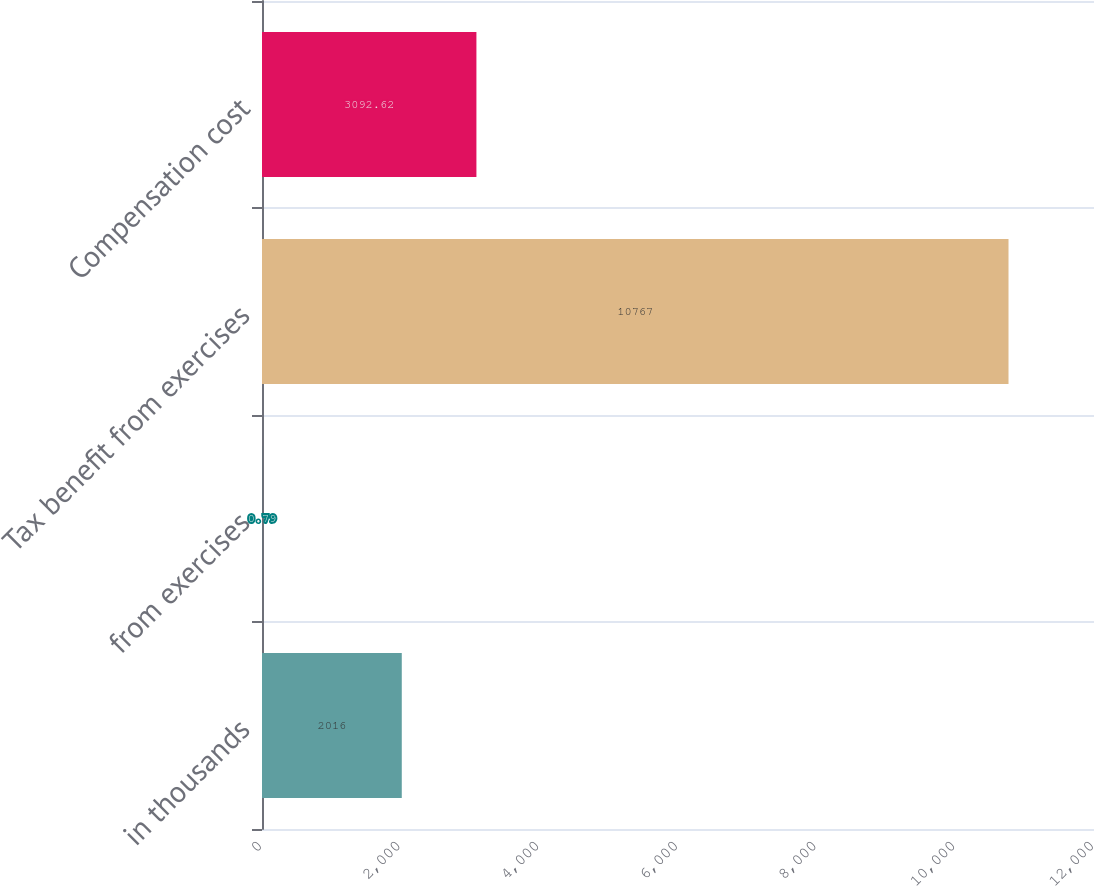<chart> <loc_0><loc_0><loc_500><loc_500><bar_chart><fcel>in thousands<fcel>from exercises<fcel>Tax benefit from exercises<fcel>Compensation cost<nl><fcel>2016<fcel>0.79<fcel>10767<fcel>3092.62<nl></chart> 